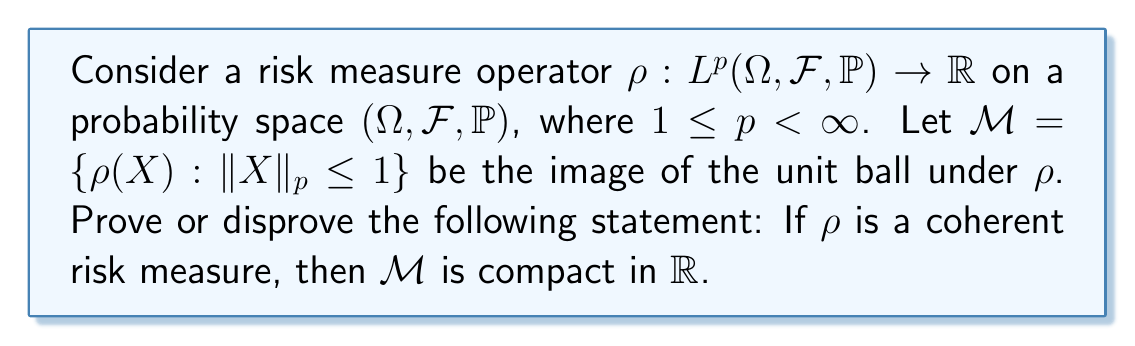Teach me how to tackle this problem. To examine the compactness of $\mathcal{M}$, we'll follow these steps:

1) Recall that a coherent risk measure satisfies four properties: monotonicity, sub-additivity, positive homogeneity, and translation invariance.

2) In $\mathbb{R}$, compactness is equivalent to closed and bounded.

3) First, let's prove that $\mathcal{M}$ is bounded:
   - By positive homogeneity, $\rho(\lambda X) = \lambda \rho(X)$ for $\lambda \geq 0$.
   - For any $X$ with $\|X\|_p \leq 1$, we have $X \leq \|X\|_p \leq 1$ almost surely.
   - By monotonicity, $\rho(X) \leq \rho(1) = \rho(1 \cdot 1_\Omega)$, where $1_\Omega$ is the constant function 1.
   - Similarly, $\rho(-X) \leq \rho(1)$, so $-\rho(1) \leq \rho(X)$ by positive homogeneity.
   - Therefore, $\mathcal{M} \subseteq [-\rho(1), \rho(1)]$, which is bounded.

4) Now, let's show that $\mathcal{M}$ is closed:
   - Consider a sequence $\{\rho(X_n)\}$ in $\mathcal{M}$ converging to some $y \in \mathbb{R}$.
   - We need to show that $y \in \mathcal{M}$.
   - However, this is where the statement fails. In infinite-dimensional spaces, the unit ball is not compact in the norm topology.
   - There's no guarantee that we can find a convergent subsequence of $\{X_n\}$ in $L^p$.
   - Without such a convergent subsequence, we can't ensure that $y = \rho(X)$ for some $X$ with $\|X\|_p \leq 1$.

5) Counter-example:
   - Let $\Omega = [0,1]$ with Lebesgue measure, and $p=2$.
   - Define $\rho(X) = \mathbb{E}[X] + \sqrt{\text{Var}(X)}$ (this is a coherent risk measure).
   - Consider $X_n(t) = \sqrt{2} \sin(2\pi n t)$. We have $\|X_n\|_2 = 1$ for all $n$.
   - $\rho(X_n) = 0 + 1 = 1$ for all $n$, but there's no $X$ in the unit ball of $L^2[0,1]$ such that $\rho(X) = 1$.

Therefore, the statement is false. While $\mathcal{M}$ is bounded, it may not be closed, and thus not compact in $\mathbb{R}$.
Answer: The statement is false. While $\mathcal{M}$ is bounded in $\mathbb{R}$, it may not be closed, and therefore not compact, even when $\rho$ is a coherent risk measure. 